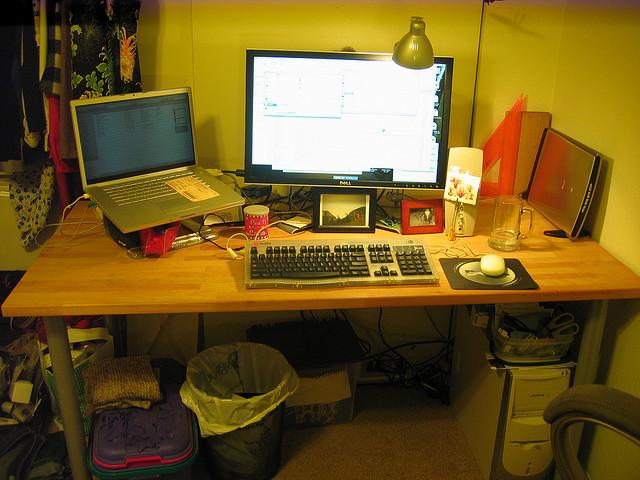What kind of cup is sat on the desk next to the computer mouse? Please explain your reasoning. mug. One can see the glass stein located near the mouse. 